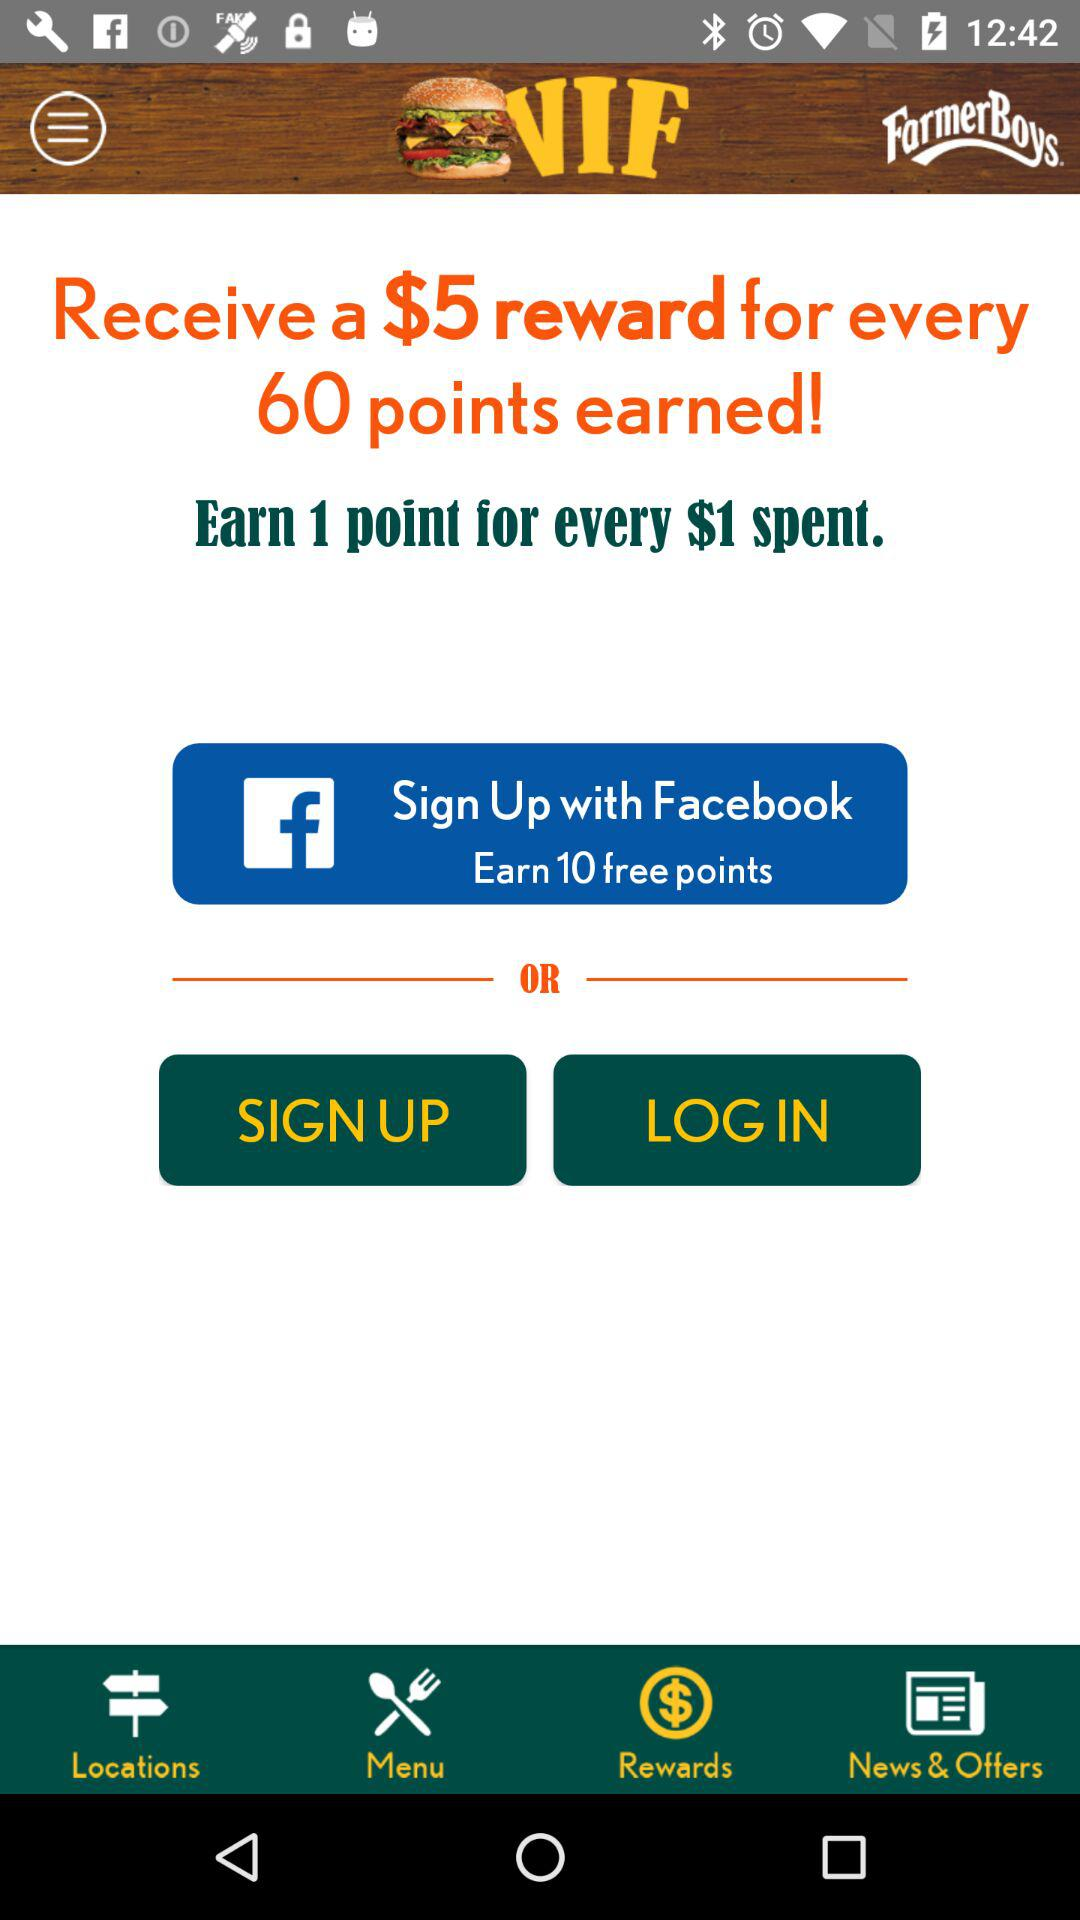What are the given sign-up options? The given sign-up option is "Facebook". 